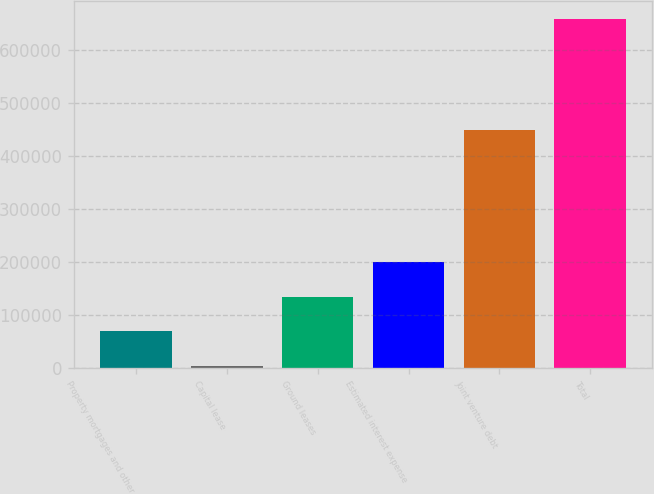Convert chart to OTSL. <chart><loc_0><loc_0><loc_500><loc_500><bar_chart><fcel>Property mortgages and other<fcel>Capital lease<fcel>Ground leases<fcel>Estimated interest expense<fcel>Joint venture debt<fcel>Total<nl><fcel>68461.2<fcel>2794<fcel>134128<fcel>199796<fcel>449740<fcel>659466<nl></chart> 